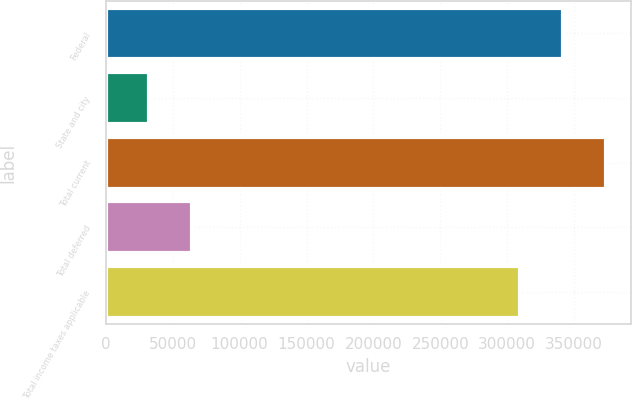Convert chart. <chart><loc_0><loc_0><loc_500><loc_500><bar_chart><fcel>Federal<fcel>State and city<fcel>Total current<fcel>Total deferred<fcel>Total income taxes applicable<nl><fcel>341438<fcel>32344<fcel>373599<fcel>64504.4<fcel>309278<nl></chart> 